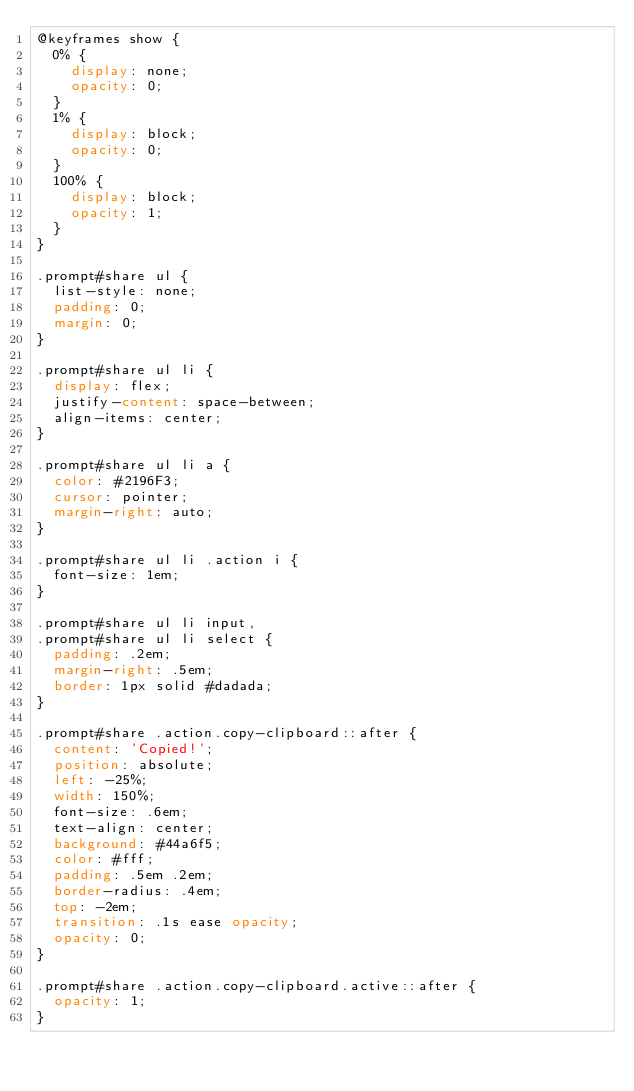Convert code to text. <code><loc_0><loc_0><loc_500><loc_500><_CSS_>@keyframes show {
  0% {
    display: none;
    opacity: 0;
  }
  1% {
    display: block;
    opacity: 0;
  }
  100% {
    display: block;
    opacity: 1;
  }
}

.prompt#share ul {
  list-style: none;
  padding: 0;
  margin: 0;
}

.prompt#share ul li {
  display: flex;
  justify-content: space-between;
  align-items: center;
}

.prompt#share ul li a {
  color: #2196F3;
  cursor: pointer;
  margin-right: auto;
}

.prompt#share ul li .action i {
  font-size: 1em;
}

.prompt#share ul li input,
.prompt#share ul li select {
  padding: .2em;
  margin-right: .5em;
  border: 1px solid #dadada;
}

.prompt#share .action.copy-clipboard::after {
  content: 'Copied!';
  position: absolute;
  left: -25%;
  width: 150%;
  font-size: .6em;
  text-align: center;
  background: #44a6f5;
  color: #fff;
  padding: .5em .2em;
  border-radius: .4em;
  top: -2em;
  transition: .1s ease opacity;
  opacity: 0;
}

.prompt#share .action.copy-clipboard.active::after {
  opacity: 1;
}

</code> 